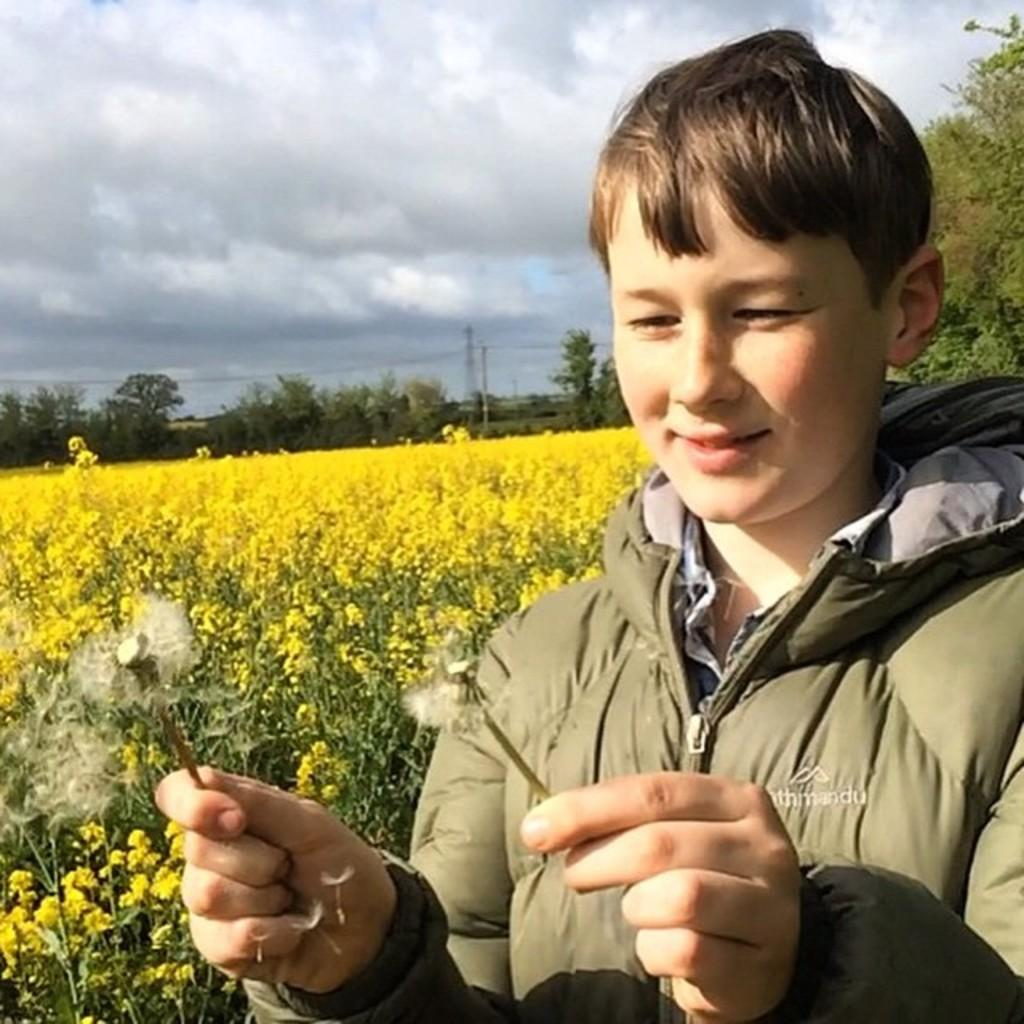Who is present in the image? There is a person in the image. What is the person holding? The person is holding flowers. What can be seen in the background of the image? There are plants with yellow flowers, trees, poles, and the sky visible in the background. What type of industry can be seen in the background of the image? There is no industry present in the background of the image; it features plants, trees, poles, and the sky. Is the image taken during the night or day? The image does not provide any information about the time of day, but the sky is visible, which suggests it might be daytime. 